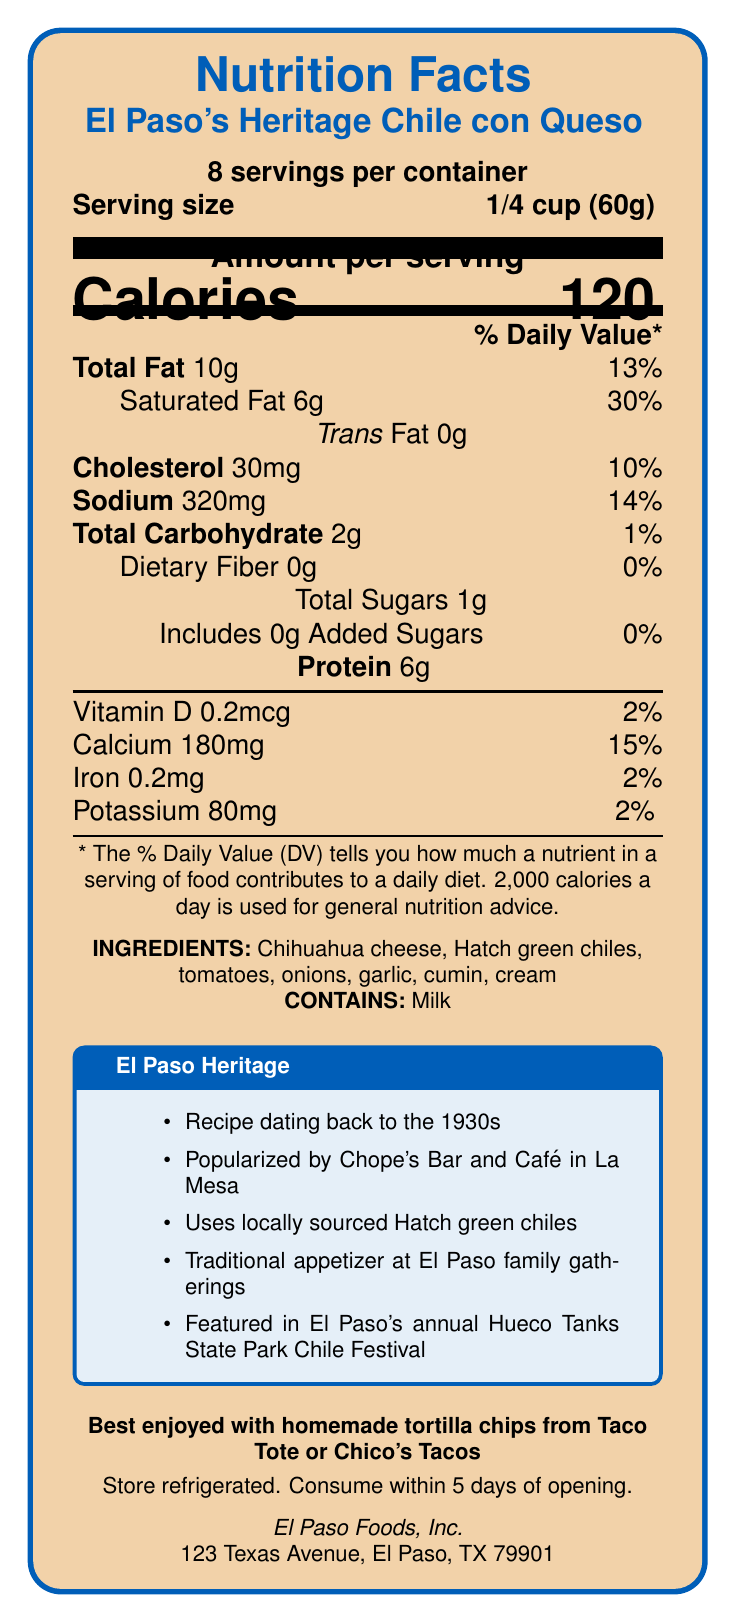what is the serving size? The serving size is clearly mentioned as 1/4 cup (60g) in the document.
Answer: 1/4 cup (60g) how many calories are in one serving? The document states that each serving contains 120 calories.
Answer: 120 what is the daily value percentage of saturated fat per serving? The document lists that one serving contains 30% of the daily value for saturated fat.
Answer: 30% how much protein is in one serving? The amount of protein per serving is 6g, as indicated in the document.
Answer: 6g how long should the product be consumed after opening? The storage instructions specify that the product should be consumed within 5 days of opening.
Answer: 5 days which type of cheese is used in the ingredients? A. Cheddar B. Mozzarella C. Chihuahua The ingredients list mentions "Chihuahua cheese."
Answer: C what is the main ingredient that reflects local sourcing in El Paso? A. Tomatoes B. Hatch green chiles C. Garlic The document highlights the use of locally sourced Hatch green chiles.
Answer: B is there any dietary fiber in the product? The document indicates that the dietary fiber content is 0g.
Answer: No is this product suitable for someone with a milk allergy? The allergens listed in the document include milk.
Answer: No describe the historical significance of this product The historical notes describe its origins, popularization, and cultural importance in El Paso.
Answer: The product, El Paso's Heritage Chile con Queso, holds historical significance dating back to the 1930s and was popularized by Chope's Bar and Café in La Mesa. It reflects El Paso's unique Tex-Mex culinary heritage and uses locally sourced Hatch green chiles. It is a traditional appetizer at El Paso family gatherings and is featured in the annual Hueco Tanks State Park Chile Festival. what type of festivals is this product featured in? The document mentions that this product is featured in the Hueco Tanks State Park Chile Festival.
Answer: Hueco Tanks State Park Chile Festival how much sodium is in one serving? The document shows that one serving contains 320mg of sodium.
Answer: 320mg what is the amount of Vitamin D in one serving? According to the document, there is 0.2mcg of Vitamin D per serving.
Answer: 0.2mcg does the product contain any added sugars? The document specifies that the product contains 0g of added sugars.
Answer: No what is the address of the manufacturer? The manufacturer's address is listed as 123 Texas Avenue, El Paso, TX 79901.
Answer: 123 Texas Avenue, El Paso, TX 79901 what is the definition of Tex-Mex cuisine? The document mentions the term "Tex-Mex" but does not provide a definition for it.
Answer: Not enough information 